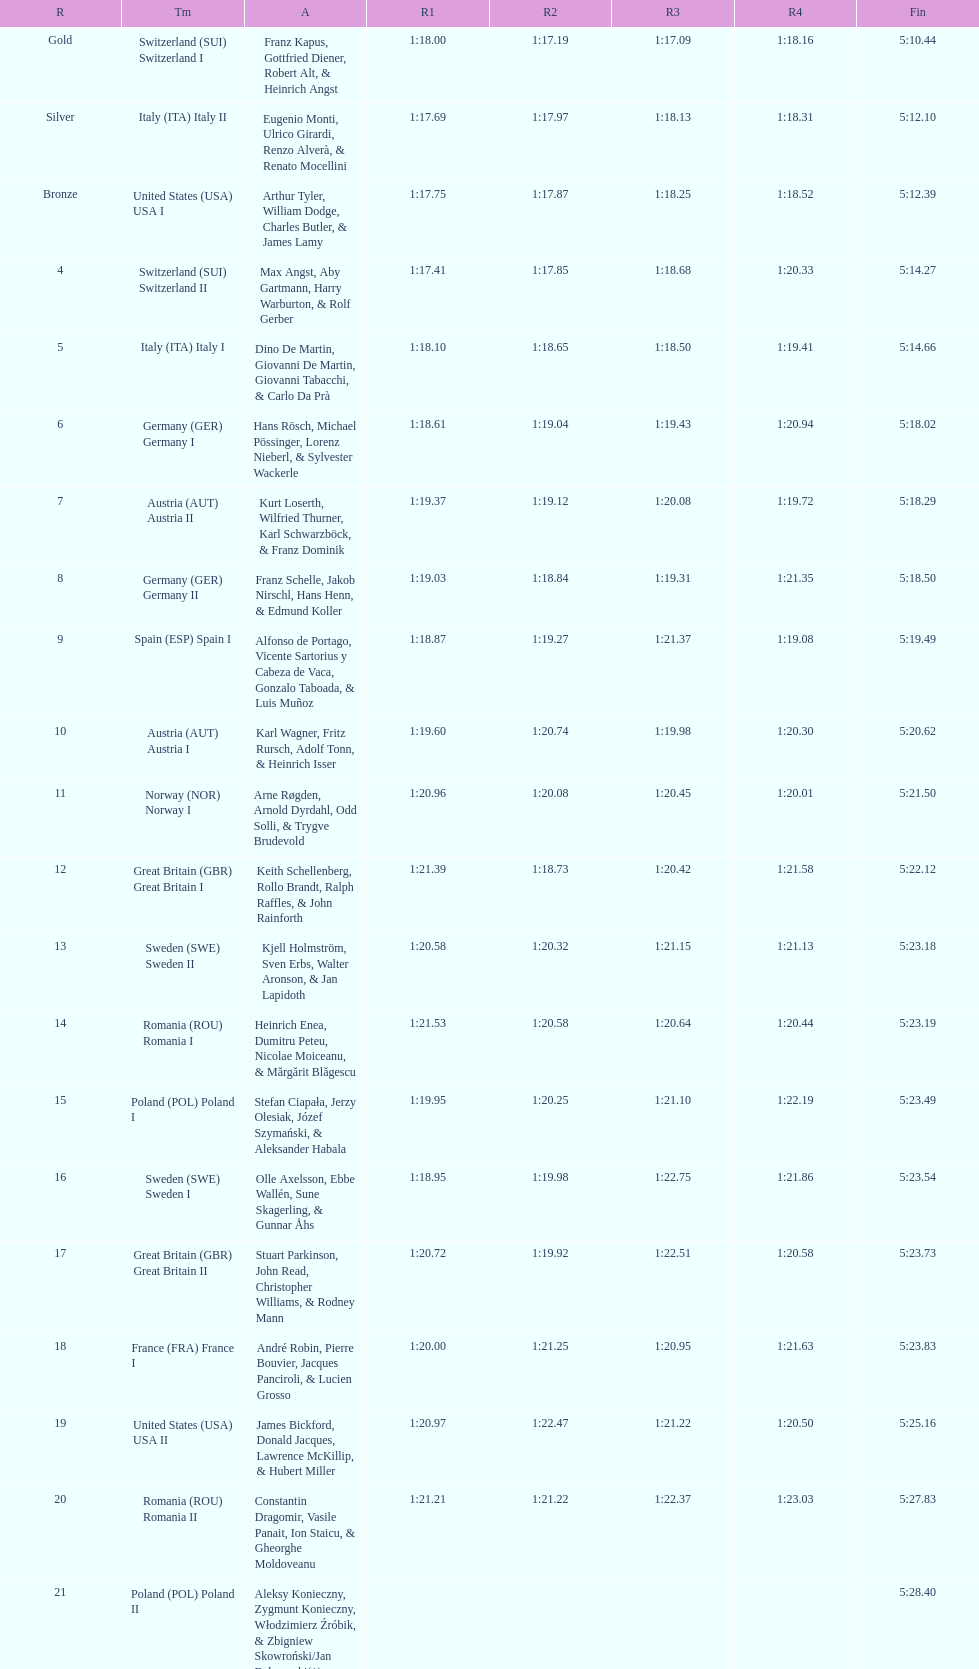What is the total amount of runs? 4. 